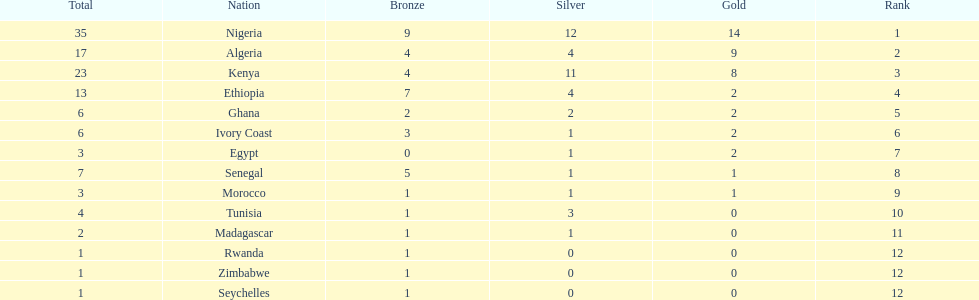Can you list the nations with only one medal to their name? Rwanda, Zimbabwe, Seychelles. 